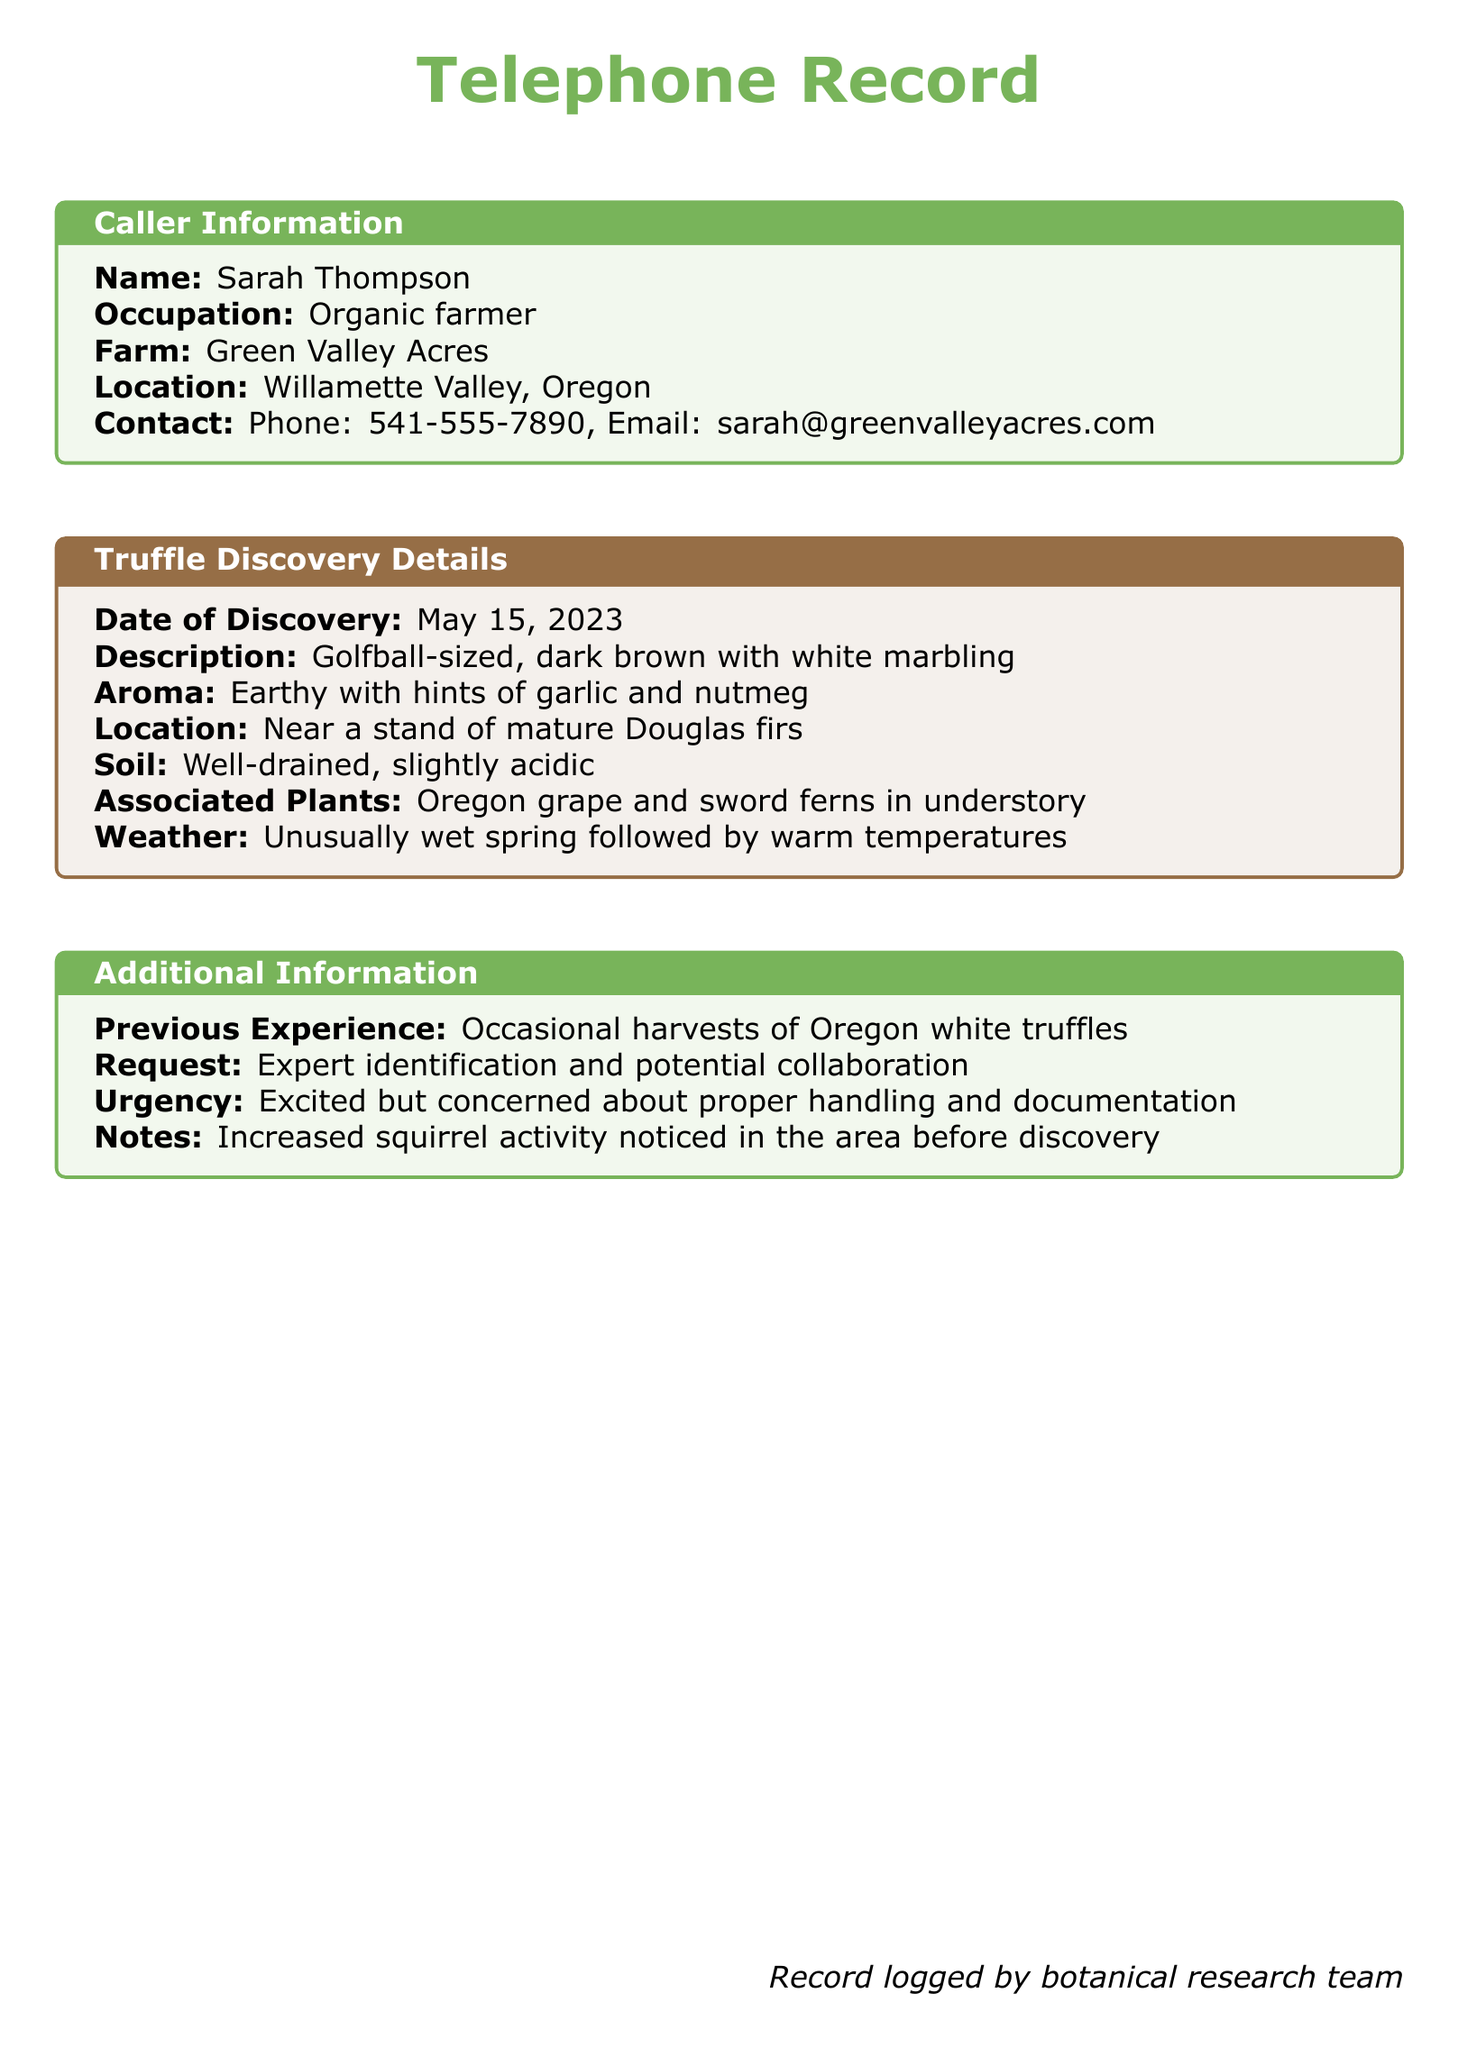what is the name of the caller? The caller's name is presented in the caller information section of the document.
Answer: Sarah Thompson what is the occupation of the caller? The occupation is listed in the caller information and specifies what the caller does.
Answer: Organic farmer when was the truffle discovered? The date of discovery is clearly stated in the truffle discovery details section.
Answer: May 15, 2023 what is the aroma of the truffle? The aroma description is provided under the truffle discovery details to convey sensory information about the truffle.
Answer: Earthy with hints of garlic and nutmeg where was the truffle found? The location details are mentioned in the truffle discovery details section, indicating where the truffle was discovered.
Answer: Near a stand of mature Douglas firs what type of soil was noted at the discovery site? The soil type is specifically mentioned under the truffle discovery details, highlighting the ecological conditions.
Answer: Well-drained, slightly acidic what previous experience does the caller have with truffles? The previous experience is outlined in the additional information section to reflect the caller's background.
Answer: Occasional harvests of Oregon white truffles why is the caller concerned? The urgency section indicates the caller's feelings and concerns about the discovery.
Answer: Proper handling and documentation what is the request made by the caller? The request is stated in the additional information, specifying what the caller desires from the experts.
Answer: Expert identification and potential collaboration 